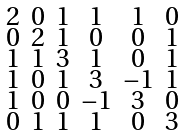Convert formula to latex. <formula><loc_0><loc_0><loc_500><loc_500>\begin{smallmatrix} 2 & 0 & 1 & 1 & 1 & 0 \\ 0 & 2 & 1 & 0 & 0 & 1 \\ 1 & 1 & 3 & 1 & 0 & 1 \\ 1 & 0 & 1 & 3 & - 1 & 1 \\ 1 & 0 & 0 & - 1 & 3 & 0 \\ 0 & 1 & 1 & 1 & 0 & 3 \end{smallmatrix}</formula> 